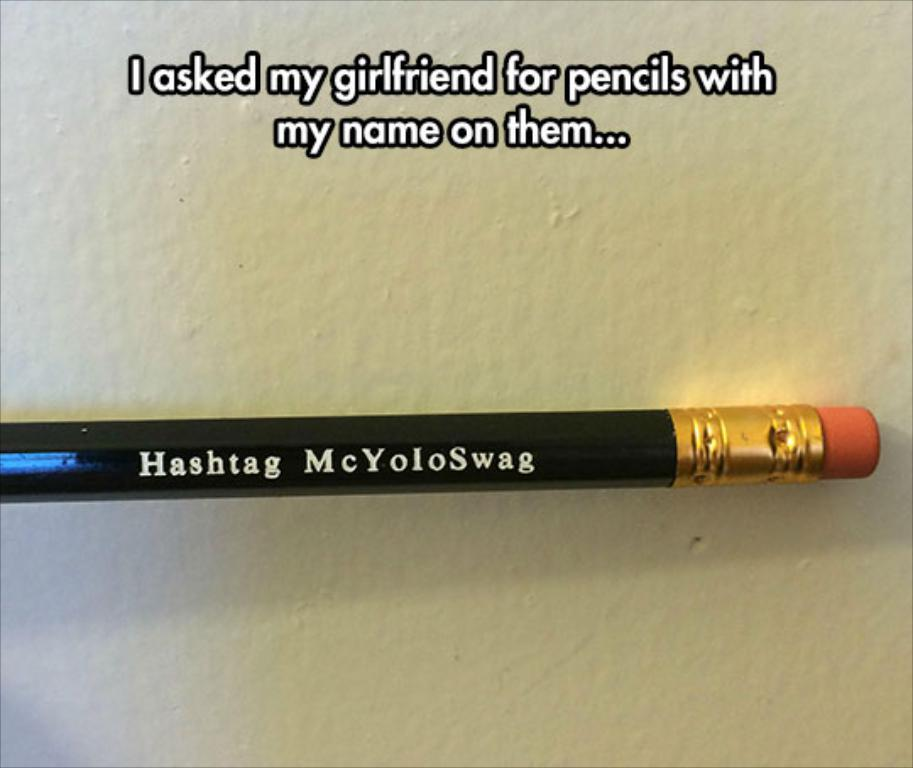What object can be seen in the image? There is a pencil in the image. What colors are present on the pencil? The pencil has black, gold, and orange colors. On what surface is the pencil placed? The pencil is on a white surface. What can be found written on the pencil? There is text written on the pencil. Are there any giants arguing over the pencil in the image? No, there are no giants or arguments present in the image; it only features a pencil on a white surface with text written on it. 